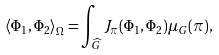<formula> <loc_0><loc_0><loc_500><loc_500>\left < \Phi _ { 1 } , \Phi _ { 2 } \right > _ { \Omega } = \int _ { \widehat { G } } J _ { \pi } ( \Phi _ { 1 } , \Phi _ { 2 } ) \mu _ { G } ( \pi ) ,</formula> 